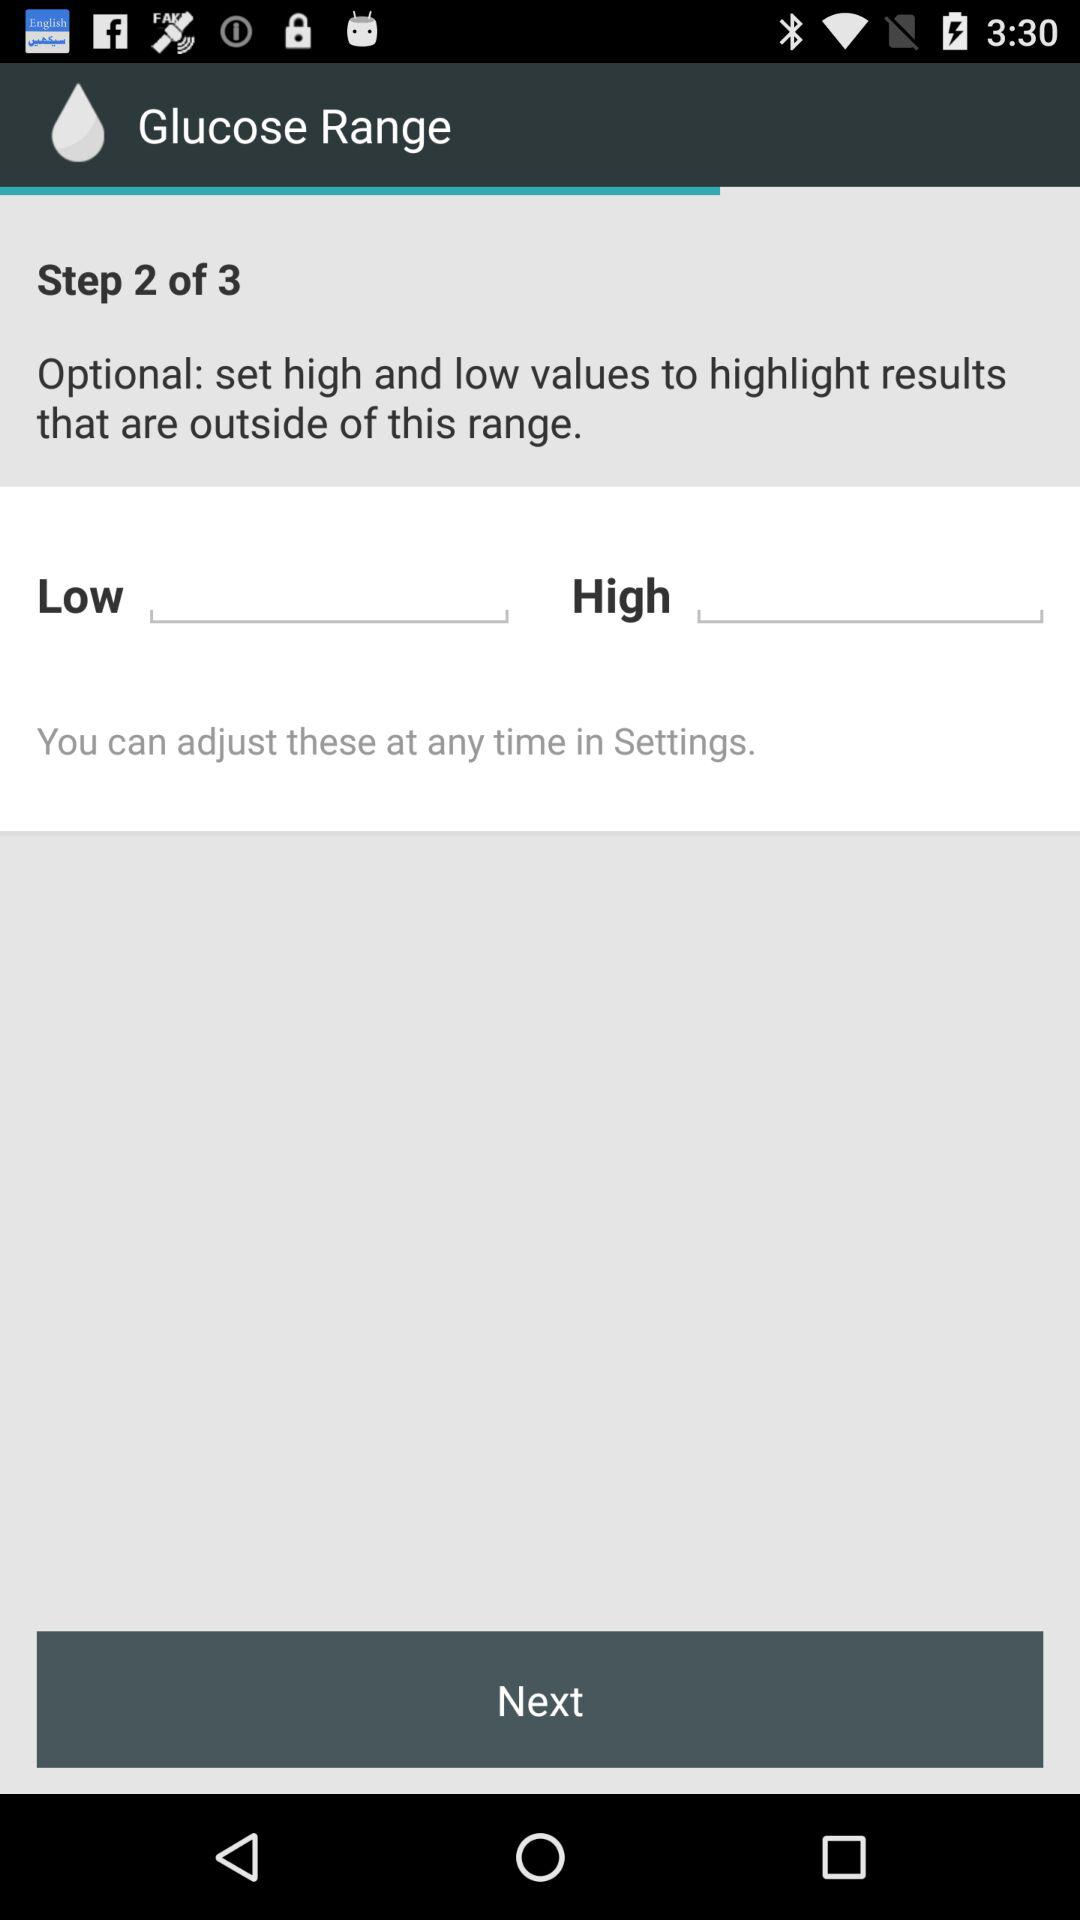At what step am I? You are on the second step. 